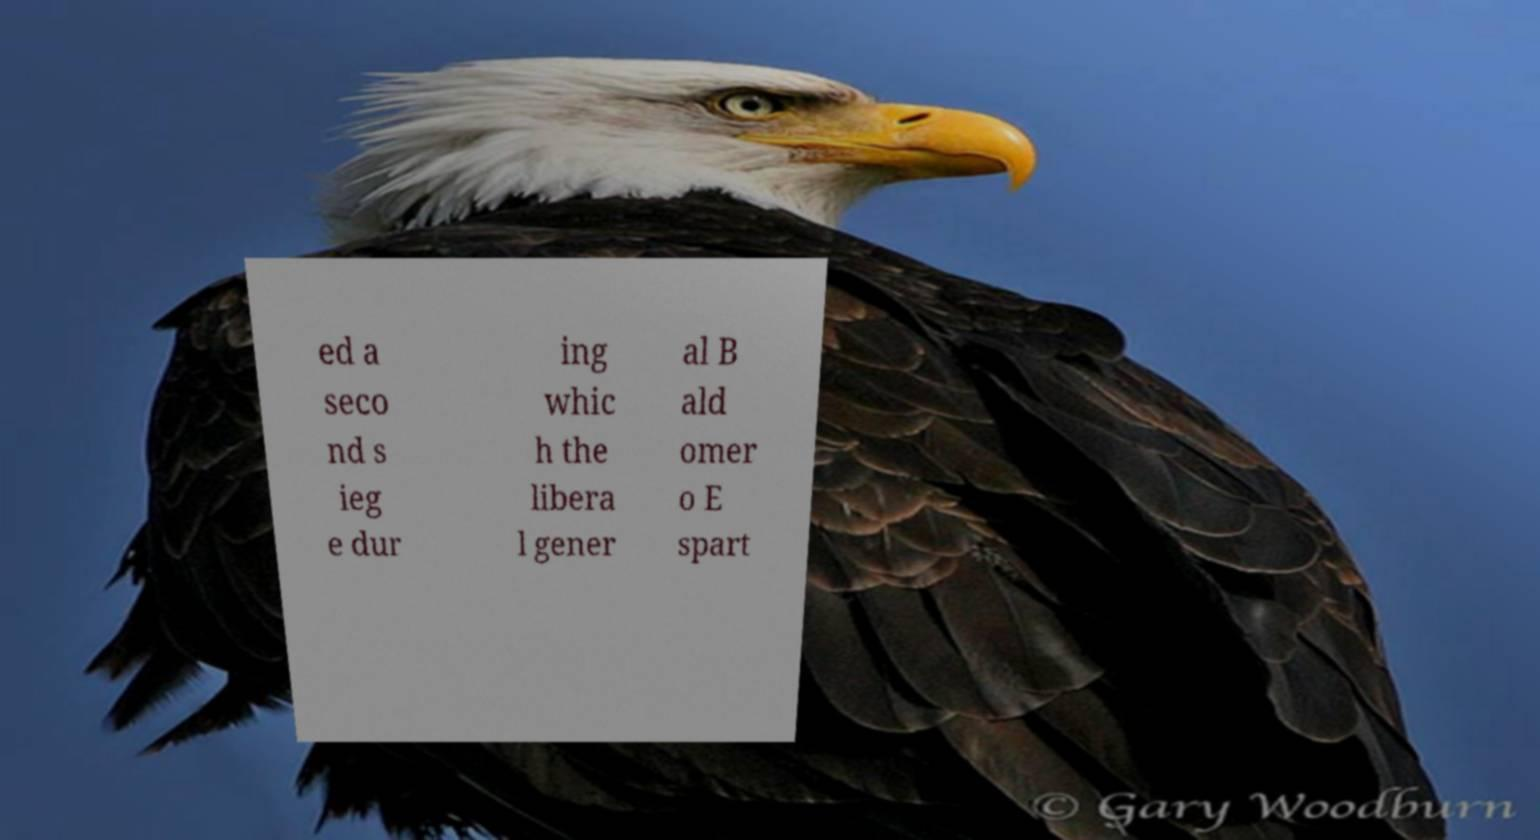Please identify and transcribe the text found in this image. ed a seco nd s ieg e dur ing whic h the libera l gener al B ald omer o E spart 